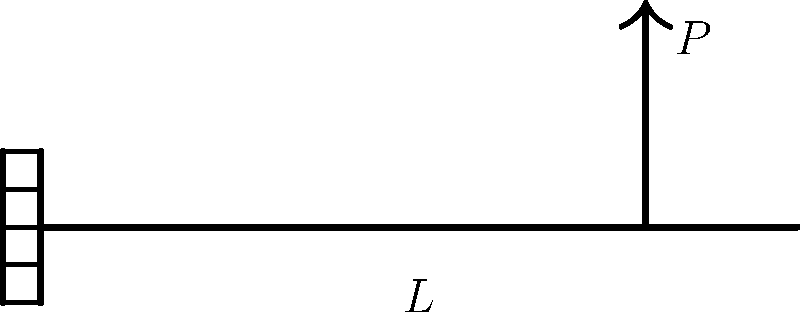For the cantilever beam shown in the diagram, subjected to a point load $P$ at its free end, how does the bending stress distribution vary along the length of the beam? Considering your experience with data structures in database administration, how might you efficiently store and retrieve this stress distribution data for multiple beam configurations? To understand the stress distribution in a cantilever beam under point load, let's follow these steps:

1. Beam configuration:
   - The beam is fixed at one end (left) and free at the other end (right).
   - A point load $P$ is applied at the free end.

2. Bending moment distribution:
   - The bending moment $M(x)$ varies linearly along the beam's length.
   - $M(x) = P(L-x)$, where $L$ is the beam length and $x$ is the distance from the fixed end.

3. Stress-moment relationship:
   - The maximum bending stress $\sigma$ at any point is given by:
     $$\sigma = \frac{My}{I}$$
   where $M$ is the bending moment, $y$ is the distance from the neutral axis, and $I$ is the moment of inertia of the cross-section.

4. Stress distribution:
   - Since $M(x)$ varies linearly and $y$ and $I$ are constant for a given cross-section, the stress distribution also varies linearly along the length.
   - The maximum stress occurs at the fixed end (x = 0) and decreases linearly to zero at the free end (x = L).

5. Data storage and retrieval:
   - To efficiently store this data, you could use a table structure with columns for position (x), bending moment (M), and stress (σ).
   - Indexing on the position column would allow for quick retrieval of stress values at specific points.
   - For multiple beam configurations, you could add additional columns for beam parameters (length, cross-section properties) and load magnitude.

6. Query optimization:
   - Given your database administration experience, you could implement partitioning based on beam configurations for faster querying of specific setups.
   - Materialized views could be used to pre-compute common stress distributions, improving query performance for frequently accessed configurations.
Answer: Linear decrease from maximum at fixed end to zero at free end; store in indexed table with position, moment, and stress columns. 